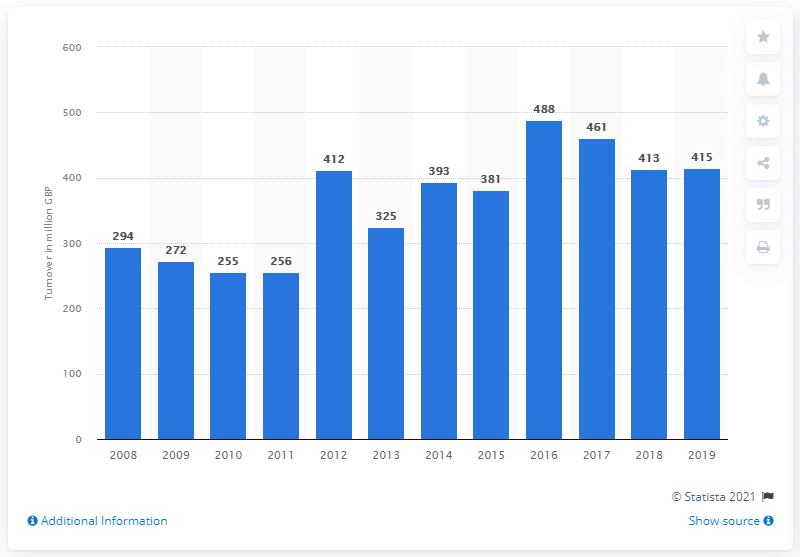Identify some key points in this picture. The increase in sales from stalls and markets in 2019 was 415. In 2019, the turnover of retail trade businesses was 415. 